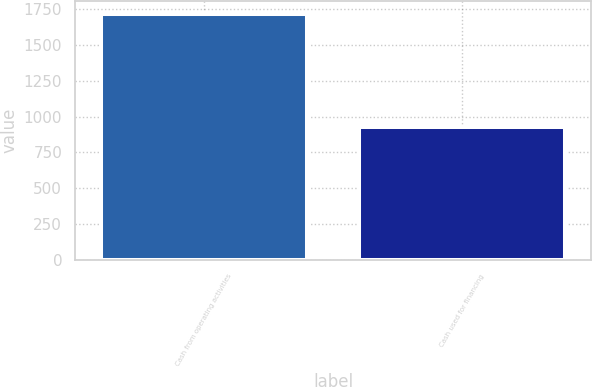Convert chart to OTSL. <chart><loc_0><loc_0><loc_500><loc_500><bar_chart><fcel>Cash from operating activities<fcel>Cash used for financing<nl><fcel>1718<fcel>929<nl></chart> 